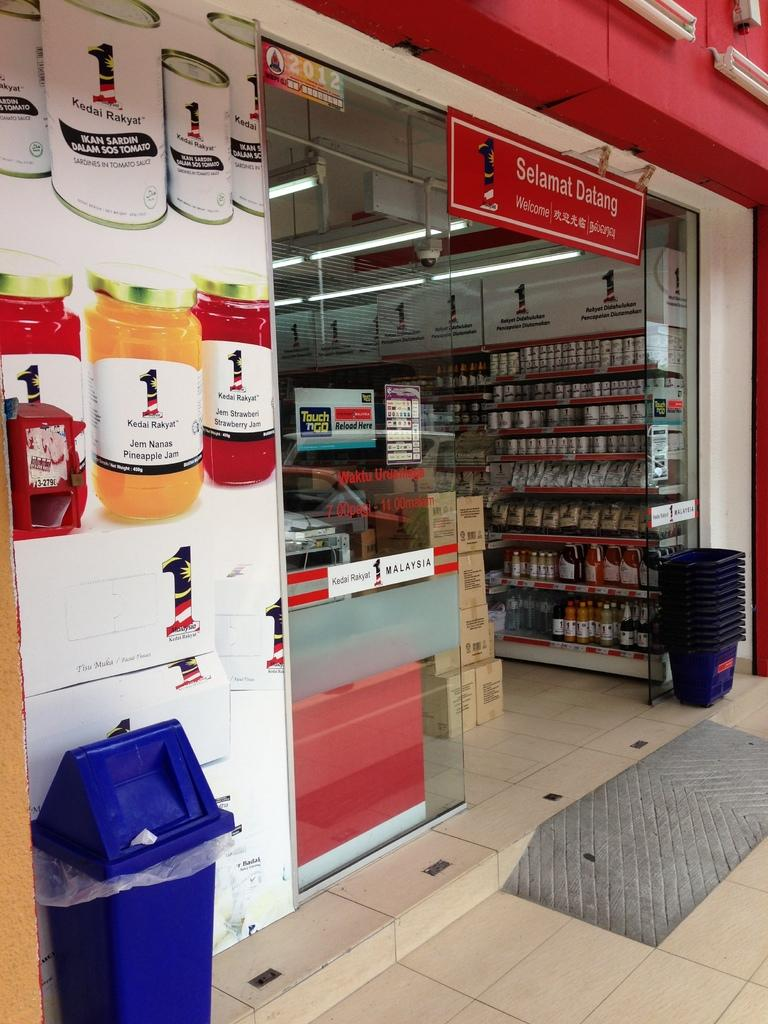<image>
Share a concise interpretation of the image provided. some bottles on a photo with one that says Jem Nanas 